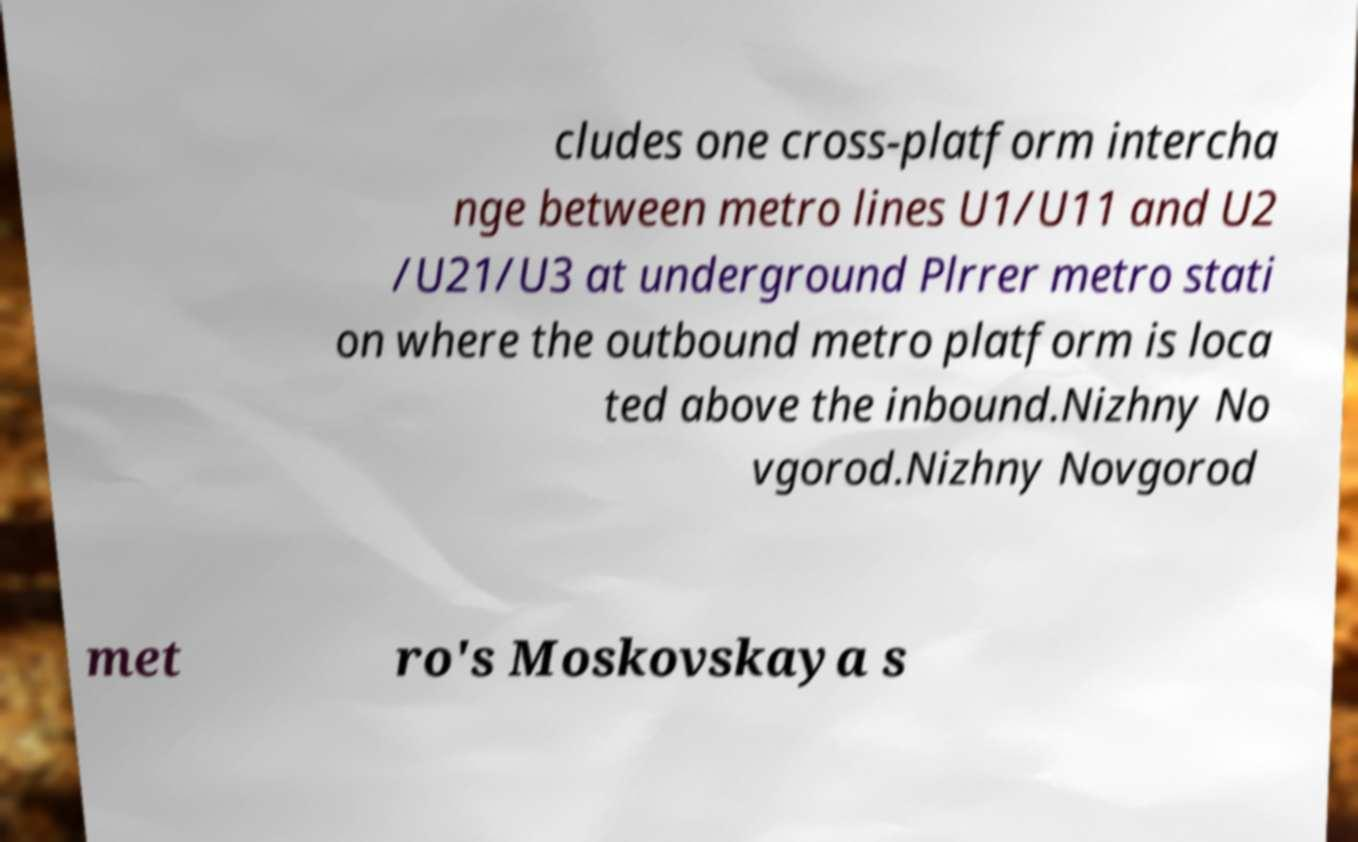Could you extract and type out the text from this image? cludes one cross-platform intercha nge between metro lines U1/U11 and U2 /U21/U3 at underground Plrrer metro stati on where the outbound metro platform is loca ted above the inbound.Nizhny No vgorod.Nizhny Novgorod met ro's Moskovskaya s 